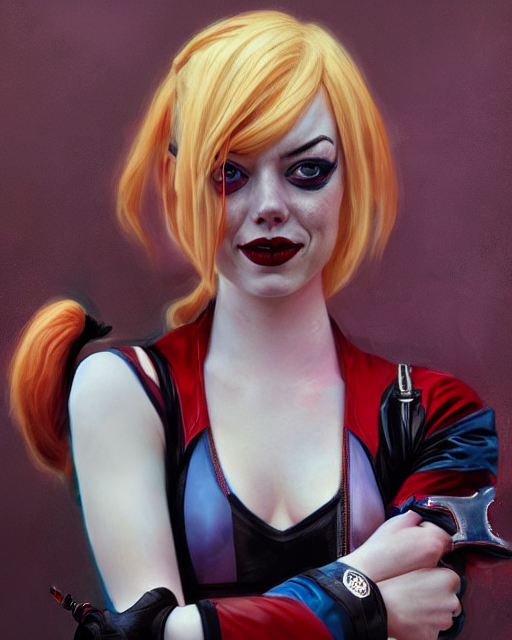Could you tell me more about the artistic choices in this image? The artistic choices in the image, such as the smoothed skin texture, the detailed rendering of the costume, and the subtle yet dramatic lighting, all contribute to a hyperrealistic painting style. The choice to depict the subject with vibrant hair contrasted against a subdued background focuses the viewer's attention on her. Even the expression, a mix between a smirk and a pensive look, adds to the artistry, hinting at a narrative and complexity behind the character being portrayed. These choices showcase the artist's intention to blend realism with imaginative elements, creating a striking visual piece that brings a fictional character to life. 